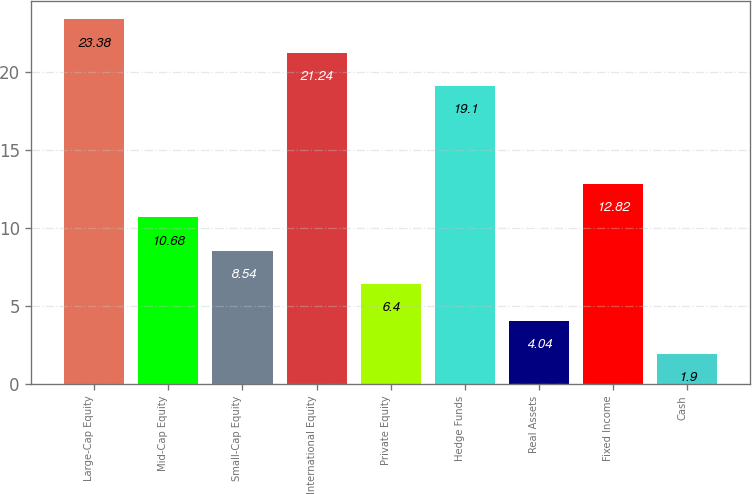Convert chart. <chart><loc_0><loc_0><loc_500><loc_500><bar_chart><fcel>Large-Cap Equity<fcel>Mid-Cap Equity<fcel>Small-Cap Equity<fcel>International Equity<fcel>Private Equity<fcel>Hedge Funds<fcel>Real Assets<fcel>Fixed Income<fcel>Cash<nl><fcel>23.38<fcel>10.68<fcel>8.54<fcel>21.24<fcel>6.4<fcel>19.1<fcel>4.04<fcel>12.82<fcel>1.9<nl></chart> 